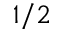<formula> <loc_0><loc_0><loc_500><loc_500>1 / 2</formula> 